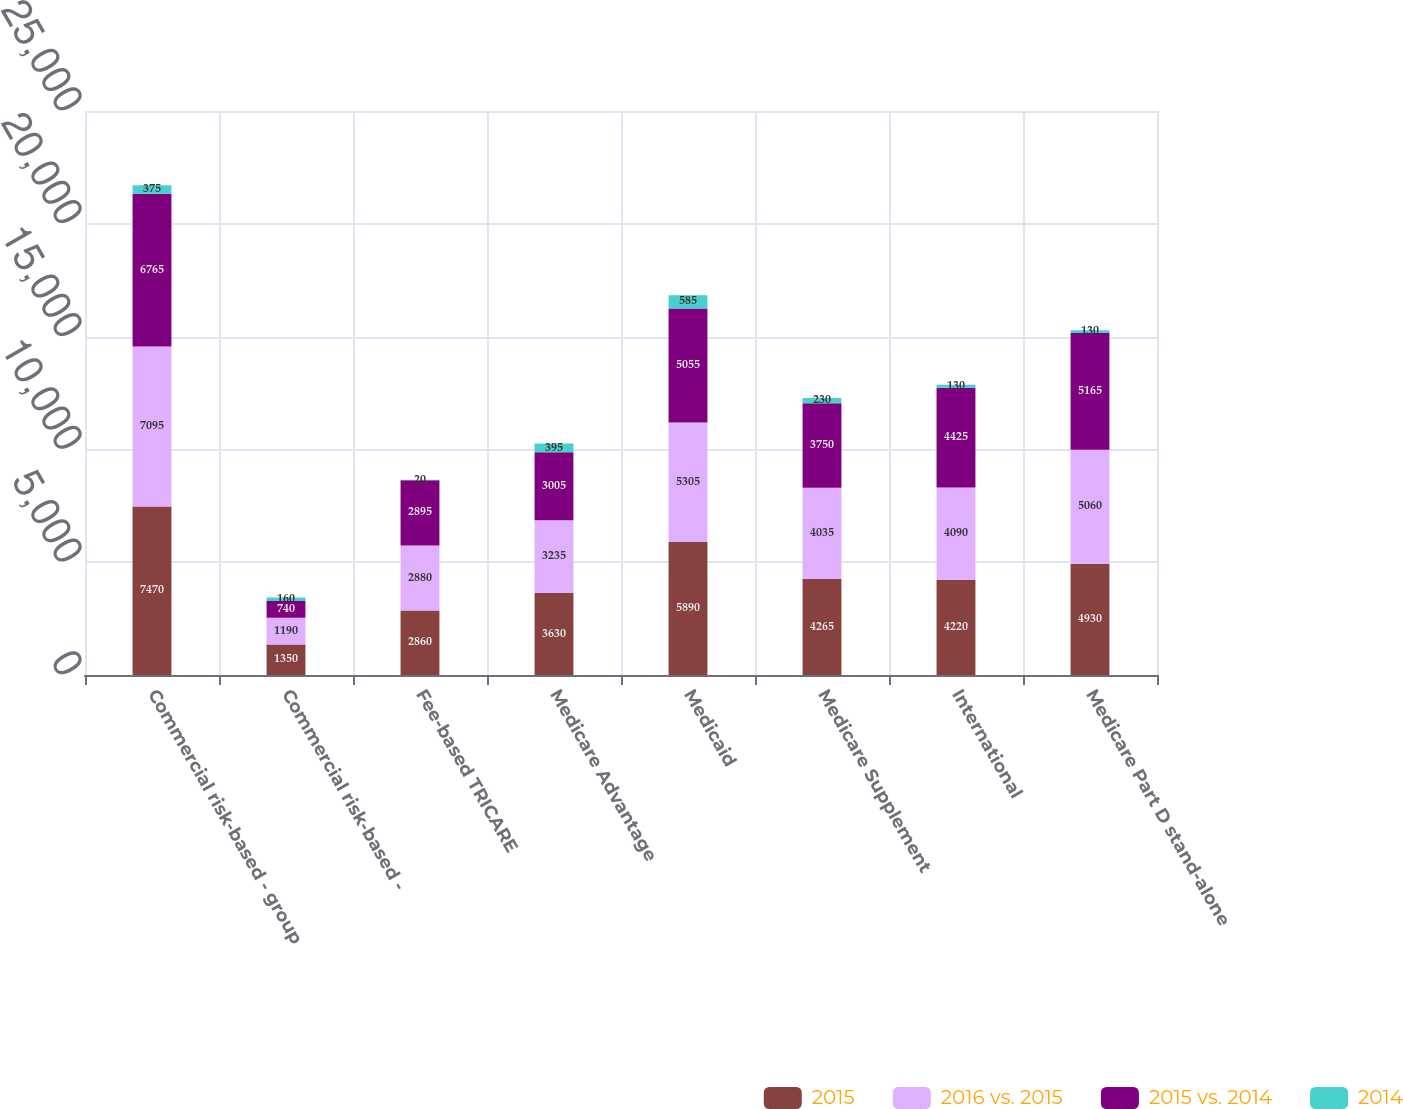<chart> <loc_0><loc_0><loc_500><loc_500><stacked_bar_chart><ecel><fcel>Commercial risk-based - group<fcel>Commercial risk-based -<fcel>Fee-based TRICARE<fcel>Medicare Advantage<fcel>Medicaid<fcel>Medicare Supplement<fcel>International<fcel>Medicare Part D stand-alone<nl><fcel>2015<fcel>7470<fcel>1350<fcel>2860<fcel>3630<fcel>5890<fcel>4265<fcel>4220<fcel>4930<nl><fcel>2016 vs. 2015<fcel>7095<fcel>1190<fcel>2880<fcel>3235<fcel>5305<fcel>4035<fcel>4090<fcel>5060<nl><fcel>2015 vs. 2014<fcel>6765<fcel>740<fcel>2895<fcel>3005<fcel>5055<fcel>3750<fcel>4425<fcel>5165<nl><fcel>2014<fcel>375<fcel>160<fcel>20<fcel>395<fcel>585<fcel>230<fcel>130<fcel>130<nl></chart> 